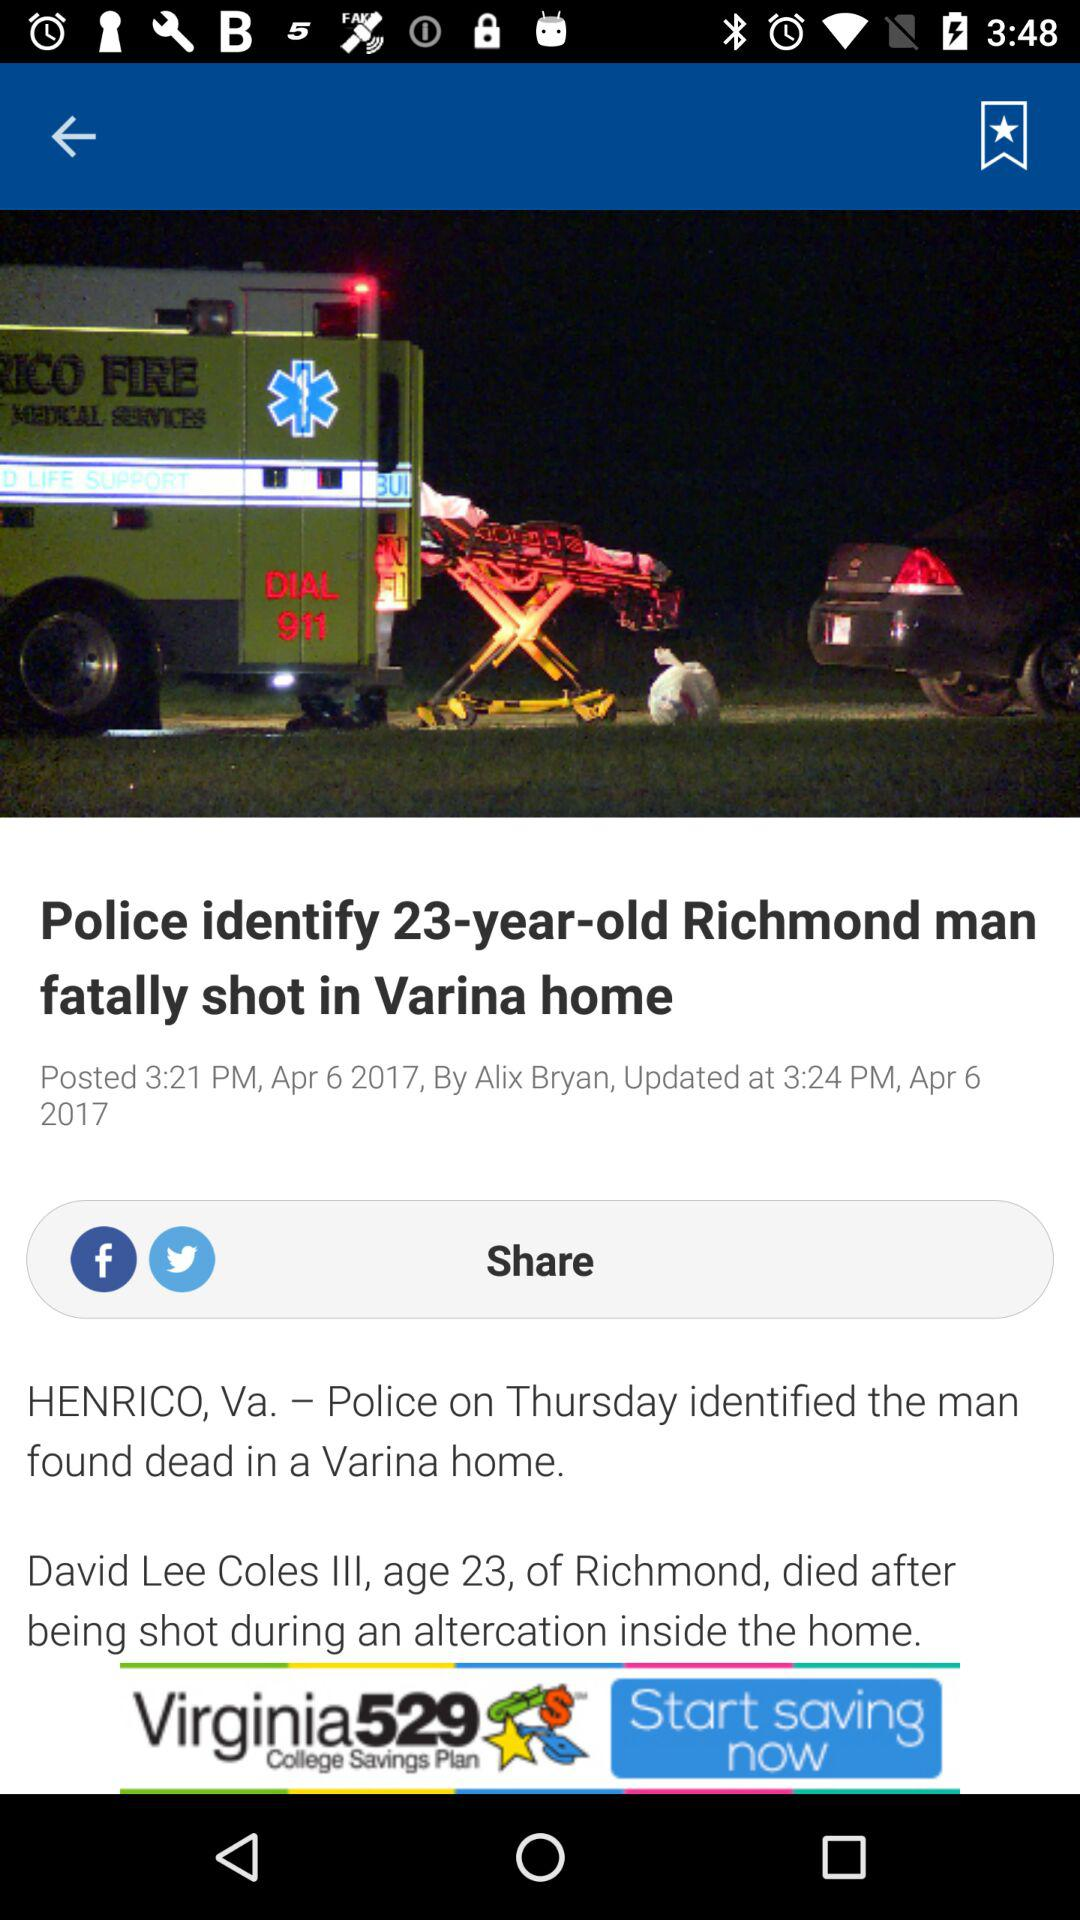Through which application can the content be shared? The content can be shared through "Facebook" and "Twitter". 